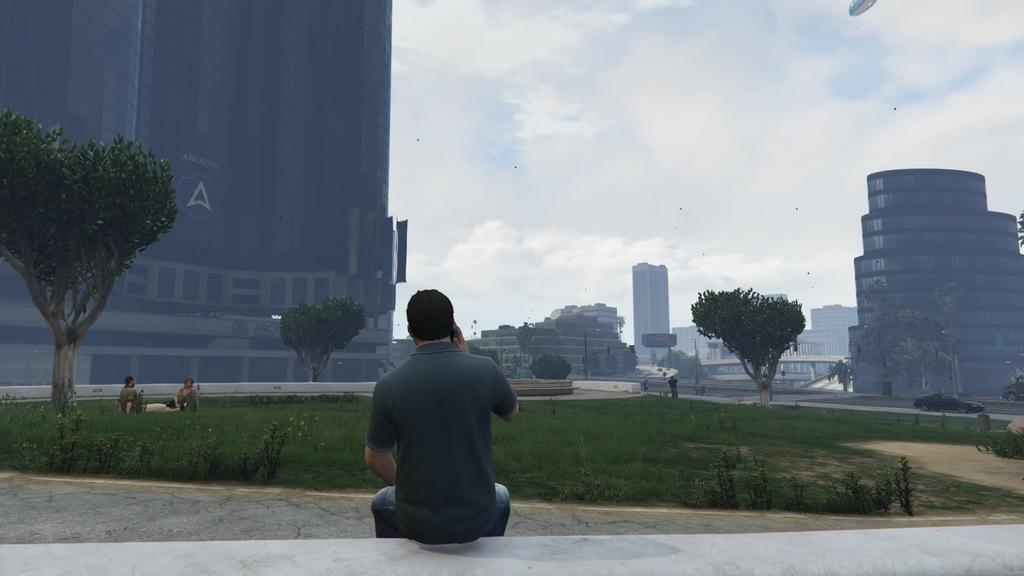What is the person in the image doing? The person is sitting on a wall in the image. What type of natural environment can be seen in the background of the image? There is grass, trees, and the sky visible in the background of the image. What type of man-made structures can be seen in the background of the image? There are buildings in the background of the image. Are there any other people visible in the image? Yes, there are people visible in the background of the image. What type of milk is being used to paint the wall in the image? There is no milk or painting activity present in the image; the person is simply sitting on the wall. 